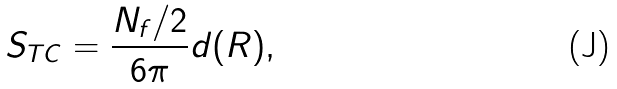<formula> <loc_0><loc_0><loc_500><loc_500>S _ { T C } = \frac { N _ { f } / 2 } { 6 \pi } d ( R ) ,</formula> 